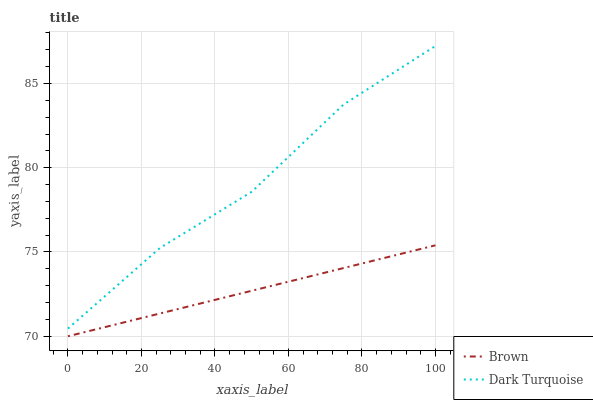Does Brown have the minimum area under the curve?
Answer yes or no. Yes. Does Dark Turquoise have the maximum area under the curve?
Answer yes or no. Yes. Does Dark Turquoise have the minimum area under the curve?
Answer yes or no. No. Is Brown the smoothest?
Answer yes or no. Yes. Is Dark Turquoise the roughest?
Answer yes or no. Yes. Is Dark Turquoise the smoothest?
Answer yes or no. No. Does Brown have the lowest value?
Answer yes or no. Yes. Does Dark Turquoise have the lowest value?
Answer yes or no. No. Does Dark Turquoise have the highest value?
Answer yes or no. Yes. Is Brown less than Dark Turquoise?
Answer yes or no. Yes. Is Dark Turquoise greater than Brown?
Answer yes or no. Yes. Does Brown intersect Dark Turquoise?
Answer yes or no. No. 